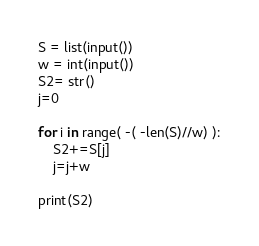<code> <loc_0><loc_0><loc_500><loc_500><_Python_>S = list(input())
w = int(input())
S2= str()
j=0

for i in range( -( -len(S)//w) ):
    S2+=S[j]
    j=j+w
    
print(S2)
</code> 